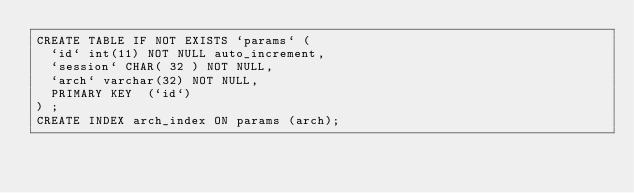Convert code to text. <code><loc_0><loc_0><loc_500><loc_500><_SQL_>CREATE TABLE IF NOT EXISTS `params` (
  `id` int(11) NOT NULL auto_increment,
  `session` CHAR( 32 ) NOT NULL,
  `arch` varchar(32) NOT NULL,
  PRIMARY KEY  (`id`)
) ;
CREATE INDEX arch_index ON params (arch);
</code> 